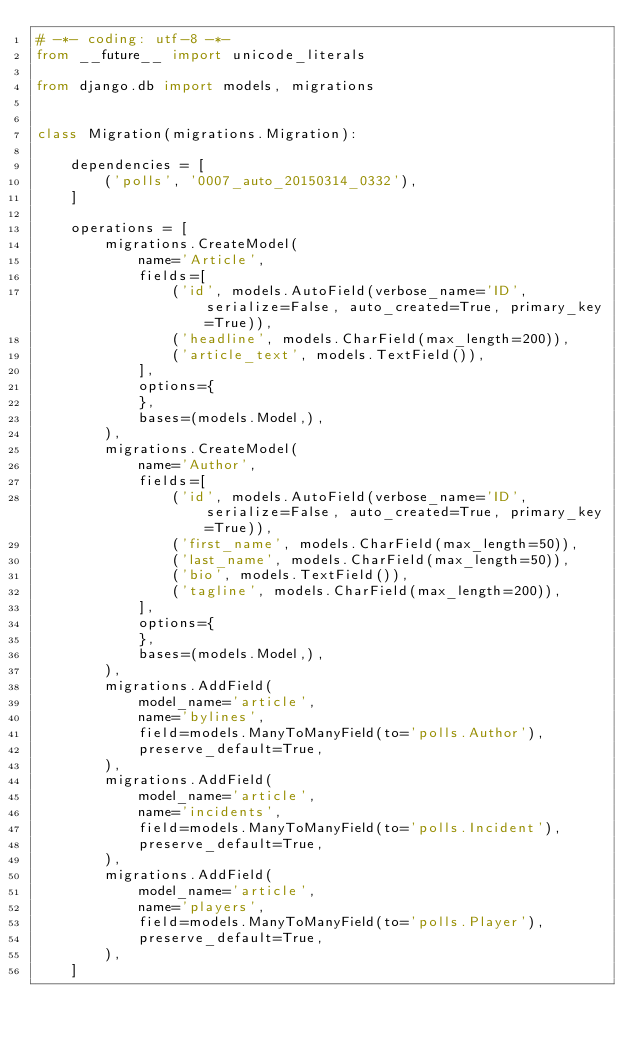<code> <loc_0><loc_0><loc_500><loc_500><_Python_># -*- coding: utf-8 -*-
from __future__ import unicode_literals

from django.db import models, migrations


class Migration(migrations.Migration):

    dependencies = [
        ('polls', '0007_auto_20150314_0332'),
    ]

    operations = [
        migrations.CreateModel(
            name='Article',
            fields=[
                ('id', models.AutoField(verbose_name='ID', serialize=False, auto_created=True, primary_key=True)),
                ('headline', models.CharField(max_length=200)),
                ('article_text', models.TextField()),
            ],
            options={
            },
            bases=(models.Model,),
        ),
        migrations.CreateModel(
            name='Author',
            fields=[
                ('id', models.AutoField(verbose_name='ID', serialize=False, auto_created=True, primary_key=True)),
                ('first_name', models.CharField(max_length=50)),
                ('last_name', models.CharField(max_length=50)),
                ('bio', models.TextField()),
                ('tagline', models.CharField(max_length=200)),
            ],
            options={
            },
            bases=(models.Model,),
        ),
        migrations.AddField(
            model_name='article',
            name='bylines',
            field=models.ManyToManyField(to='polls.Author'),
            preserve_default=True,
        ),
        migrations.AddField(
            model_name='article',
            name='incidents',
            field=models.ManyToManyField(to='polls.Incident'),
            preserve_default=True,
        ),
        migrations.AddField(
            model_name='article',
            name='players',
            field=models.ManyToManyField(to='polls.Player'),
            preserve_default=True,
        ),
    ]
</code> 